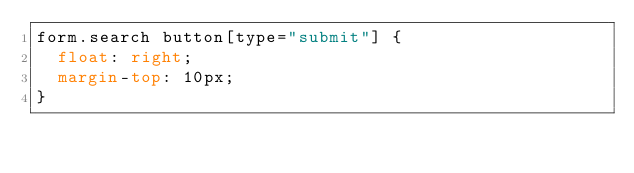Convert code to text. <code><loc_0><loc_0><loc_500><loc_500><_CSS_>form.search button[type="submit"] {
  float: right;
  margin-top: 10px;
}</code> 